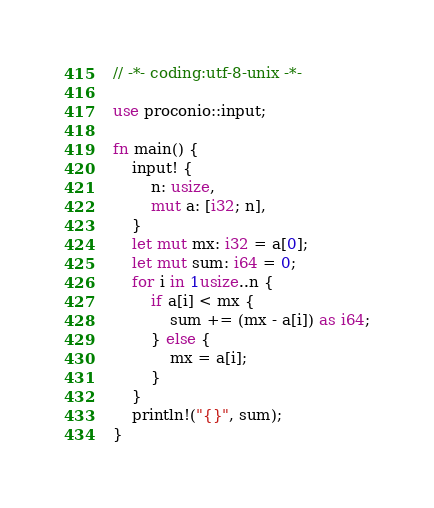<code> <loc_0><loc_0><loc_500><loc_500><_Rust_>// -*- coding:utf-8-unix -*-

use proconio::input;

fn main() {
    input! {
        n: usize,
        mut a: [i32; n],
    }
    let mut mx: i32 = a[0];
    let mut sum: i64 = 0;
    for i in 1usize..n {
        if a[i] < mx {
            sum += (mx - a[i]) as i64;
        } else {
            mx = a[i];
        }
    }
    println!("{}", sum);
}
</code> 